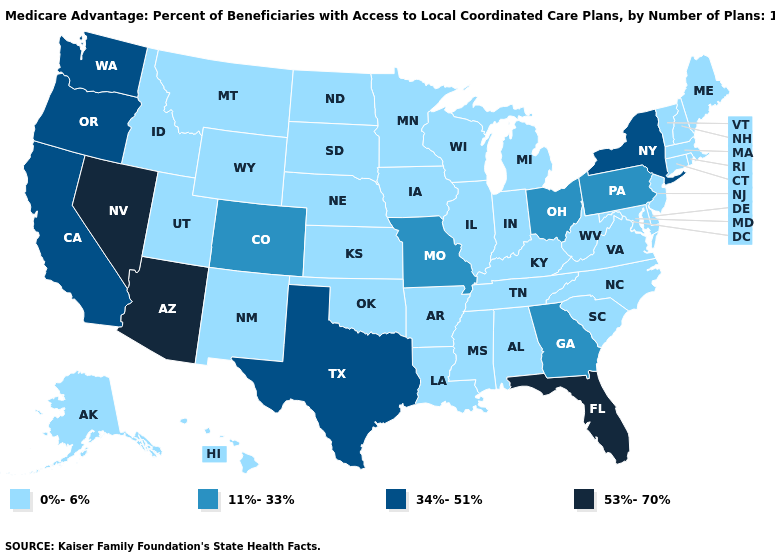Name the states that have a value in the range 11%-33%?
Be succinct. Colorado, Georgia, Missouri, Ohio, Pennsylvania. What is the value of Minnesota?
Quick response, please. 0%-6%. What is the value of Mississippi?
Write a very short answer. 0%-6%. How many symbols are there in the legend?
Concise answer only. 4. Does South Carolina have the lowest value in the South?
Give a very brief answer. Yes. What is the value of New Mexico?
Be succinct. 0%-6%. Which states have the highest value in the USA?
Short answer required. Arizona, Florida, Nevada. Which states have the lowest value in the West?
Keep it brief. Alaska, Hawaii, Idaho, Montana, New Mexico, Utah, Wyoming. Name the states that have a value in the range 0%-6%?
Quick response, please. Alaska, Alabama, Arkansas, Connecticut, Delaware, Hawaii, Iowa, Idaho, Illinois, Indiana, Kansas, Kentucky, Louisiana, Massachusetts, Maryland, Maine, Michigan, Minnesota, Mississippi, Montana, North Carolina, North Dakota, Nebraska, New Hampshire, New Jersey, New Mexico, Oklahoma, Rhode Island, South Carolina, South Dakota, Tennessee, Utah, Virginia, Vermont, Wisconsin, West Virginia, Wyoming. Does Missouri have the lowest value in the USA?
Short answer required. No. What is the value of Nevada?
Answer briefly. 53%-70%. Which states have the lowest value in the USA?
Quick response, please. Alaska, Alabama, Arkansas, Connecticut, Delaware, Hawaii, Iowa, Idaho, Illinois, Indiana, Kansas, Kentucky, Louisiana, Massachusetts, Maryland, Maine, Michigan, Minnesota, Mississippi, Montana, North Carolina, North Dakota, Nebraska, New Hampshire, New Jersey, New Mexico, Oklahoma, Rhode Island, South Carolina, South Dakota, Tennessee, Utah, Virginia, Vermont, Wisconsin, West Virginia, Wyoming. Which states hav the highest value in the South?
Be succinct. Florida. Does the map have missing data?
Quick response, please. No. What is the value of New Jersey?
Be succinct. 0%-6%. 